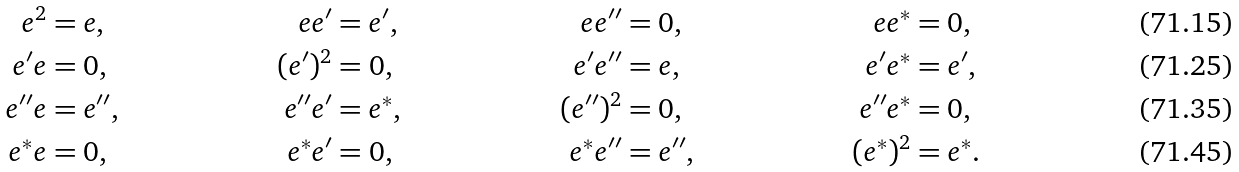<formula> <loc_0><loc_0><loc_500><loc_500>e ^ { 2 } & = e , & e e ^ { \prime } & = e ^ { \prime } , & e e ^ { \prime \prime } & = 0 , & e e ^ { * } & = 0 , \\ e ^ { \prime } e & = 0 , & ( e ^ { \prime } ) ^ { 2 } & = 0 , & e ^ { \prime } e ^ { \prime \prime } & = e , & e ^ { \prime } e ^ { * } & = e ^ { \prime } , \\ e ^ { \prime \prime } e & = e ^ { \prime \prime } , & e ^ { \prime \prime } e ^ { \prime } & = e ^ { * } , & ( e ^ { \prime \prime } ) ^ { 2 } & = 0 , & e ^ { \prime \prime } e ^ { * } & = 0 , \\ e ^ { * } e & = 0 , & e ^ { * } e ^ { \prime } & = 0 , & e ^ { * } e ^ { \prime \prime } & = e ^ { \prime \prime } , & ( e ^ { * } ) ^ { 2 } & = e ^ { * } .</formula> 